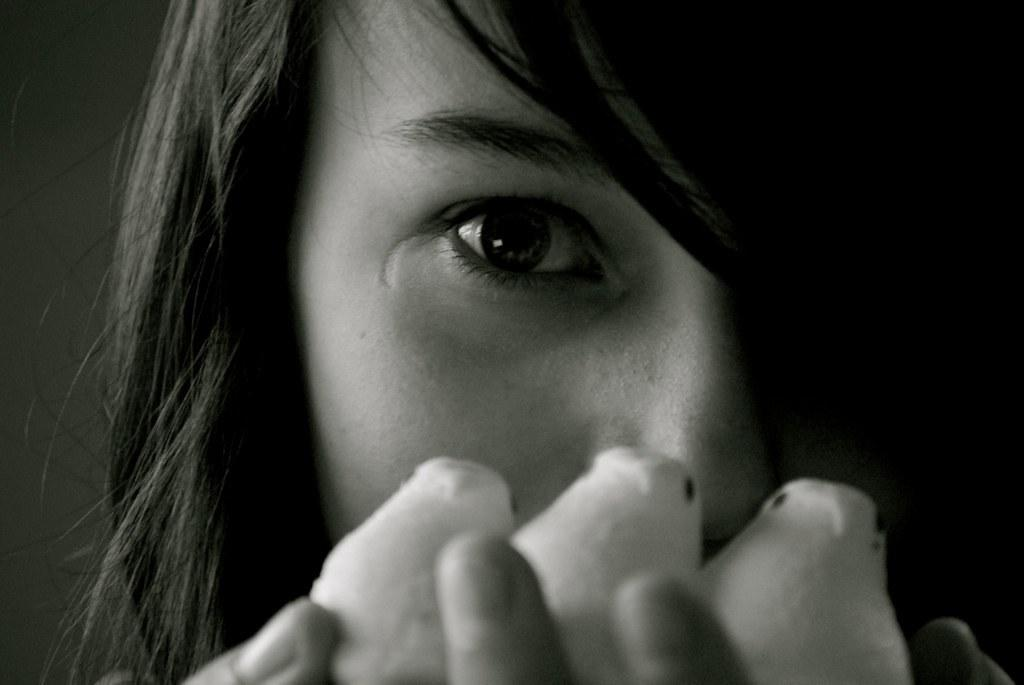What is the main subject of the image? The main subject of the image is a woman. What is the woman doing in the image? The woman is holding an object with her hand. How many trees can be seen in the image? There are no trees visible in the image; it only features a woman holding an object. What type of collar is the pet wearing in the image? There is no pet present in the image, so it is not possible to determine if a collar is being worn. 